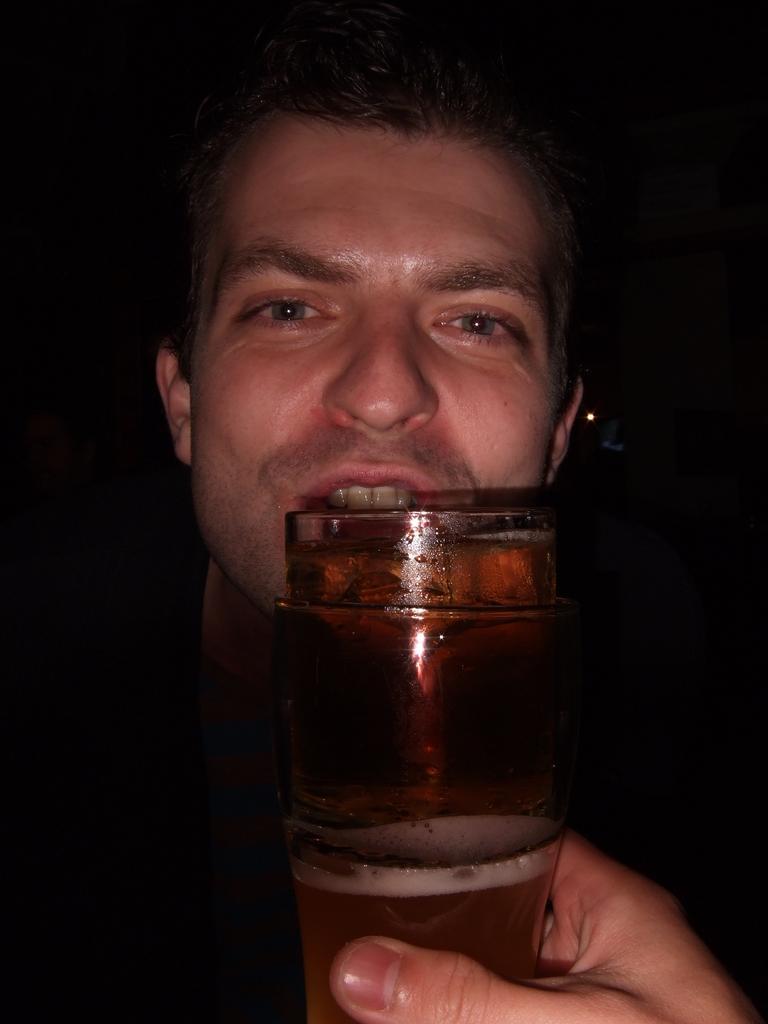Describe this image in one or two sentences. In this there is a man looking towards the camera. In front of the man there is a glass of beer. 